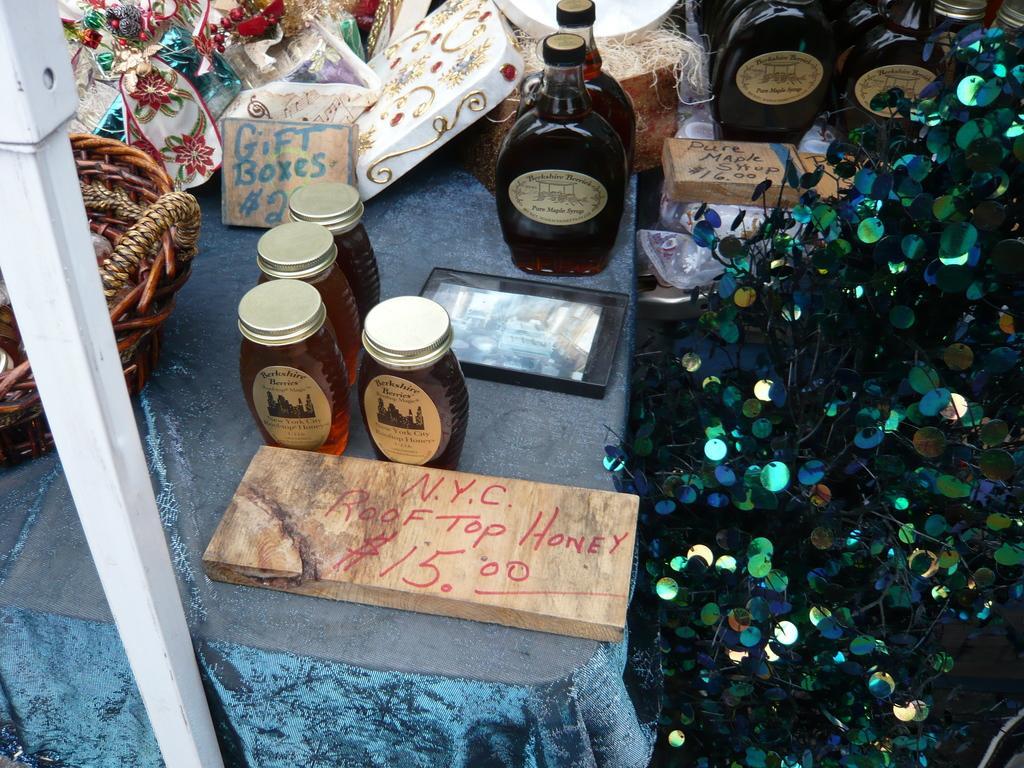In one or two sentences, can you explain what this image depicts? In the image I can see a table on which there are bottles, boxes and to the side there is a fancy plant. 